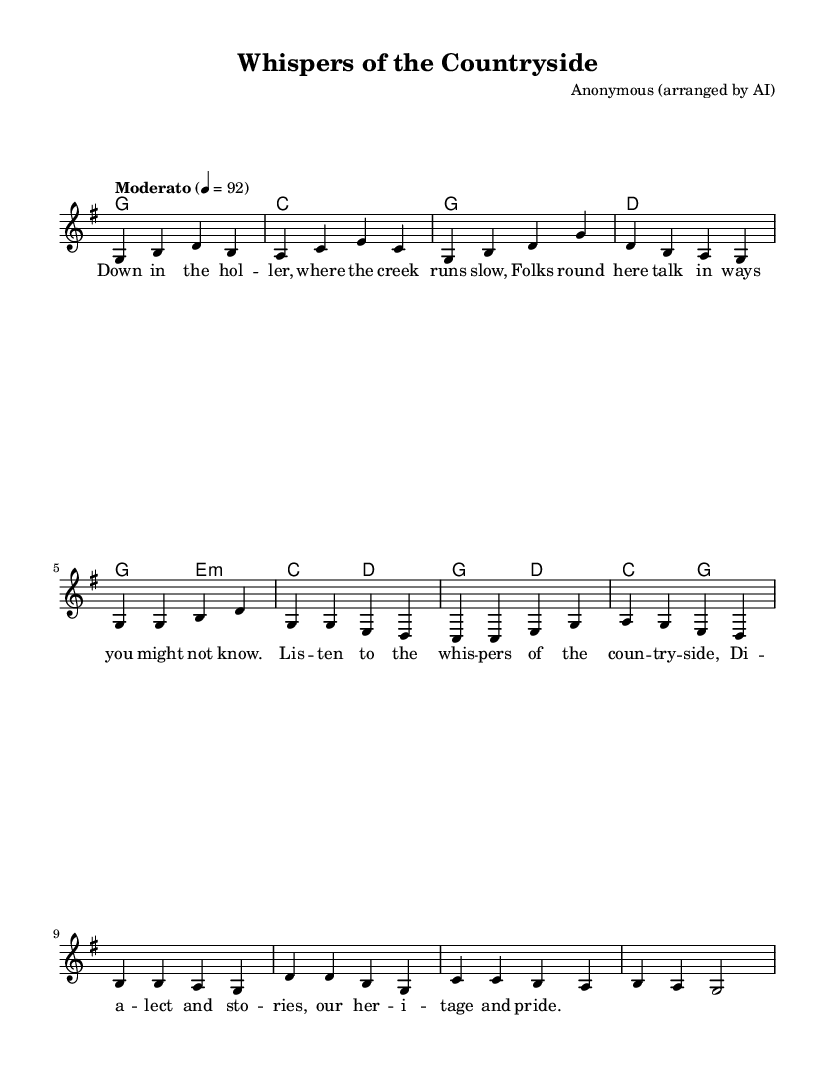What is the key signature of this music? The key signature indicates the key of the piece. By examining the music sheet, we see there is one sharp, which corresponds to the key of G major.
Answer: G major What is the time signature of this music? The time signature is notated at the beginning of the music and indicates how many beats are in a measure. The sheet shows 4/4, meaning there are 4 beats per measure.
Answer: 4/4 What is the tempo marking of the piece? The tempo marking provides the speed of the music. In this sheet music, the tempo is marked "Moderato," which typically suggests a moderate pace.
Answer: Moderato How many measures are in the verse section? By counting the measures in the verse section, identified by the lyrics and melody fragments, we can see there are four measures in total.
Answer: 4 What is the main theme reflected in the lyrics? The lyrics describe an aspect of local culture through dialect and heritage, stating the connection to the countryside and its stories. The repeated mentions of "whispers" and "heritage" highlight this theme.
Answer: Dialect and heritage How do the chords change between the verse and chorus? To analyze the chord progression, we observe that the verse uses a progression of G to E minor to C and then D, while the chorus includes G and D again, suggesting a return to primary harmonic structure. This contrast creates a feeling of resolution.
Answer: G, E minor, C, D to G, D 